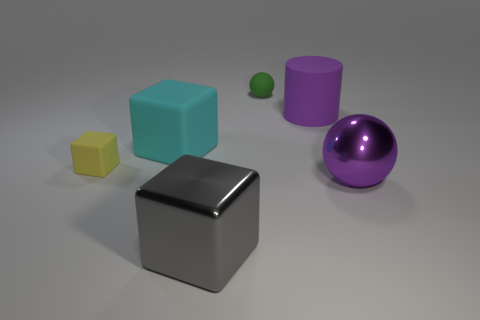Do the purple metallic object and the purple cylinder have the same size?
Provide a short and direct response. Yes. What material is the big thing that is on the left side of the big metallic object left of the large purple thing behind the small yellow block?
Make the answer very short. Rubber. Is the number of green objects in front of the big purple matte thing the same as the number of big green rubber objects?
Offer a terse response. Yes. Is there any other thing that is the same size as the cyan cube?
Your answer should be compact. Yes. What number of objects are small brown cylinders or small matte things?
Your answer should be compact. 2. What shape is the large gray object that is made of the same material as the purple sphere?
Your response must be concise. Cube. There is a cube in front of the rubber thing that is in front of the big cyan rubber thing; how big is it?
Provide a succinct answer. Large. How many small objects are either gray metallic blocks or red objects?
Keep it short and to the point. 0. How many other things are there of the same color as the tiny matte ball?
Provide a short and direct response. 0. Do the sphere behind the tiny yellow matte cube and the cube that is left of the large cyan cube have the same size?
Keep it short and to the point. Yes. 